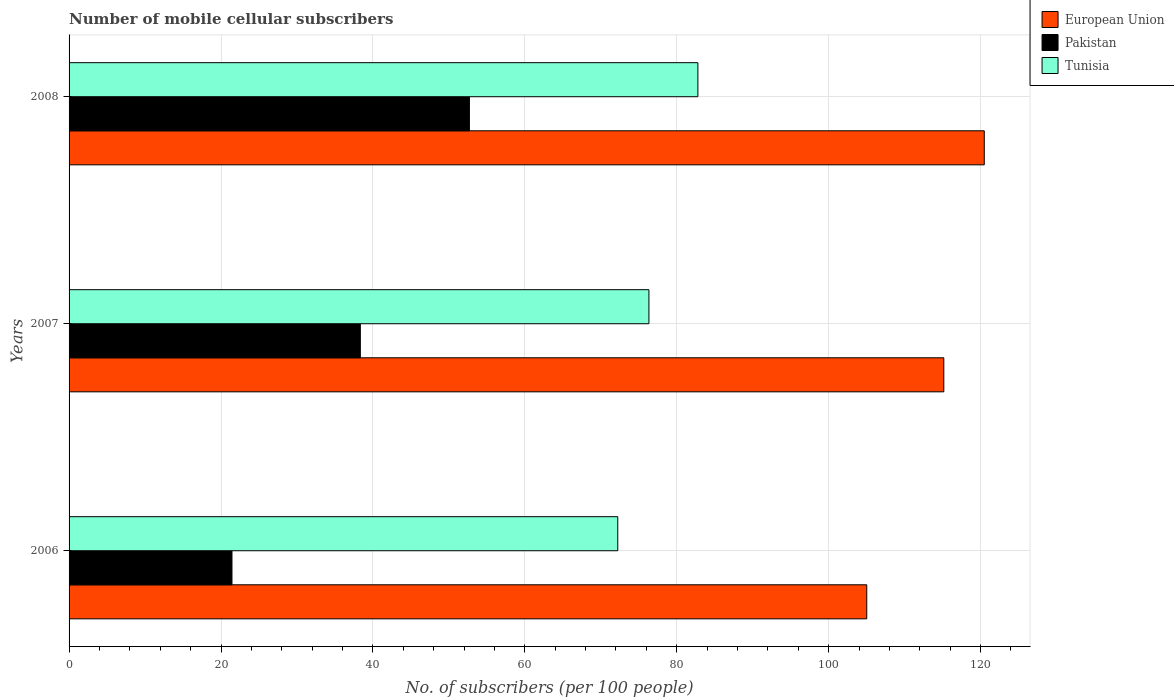How many different coloured bars are there?
Ensure brevity in your answer.  3. Are the number of bars per tick equal to the number of legend labels?
Offer a terse response. Yes. Are the number of bars on each tick of the Y-axis equal?
Your answer should be compact. Yes. How many bars are there on the 3rd tick from the top?
Provide a short and direct response. 3. How many bars are there on the 3rd tick from the bottom?
Your answer should be compact. 3. What is the label of the 3rd group of bars from the top?
Keep it short and to the point. 2006. In how many cases, is the number of bars for a given year not equal to the number of legend labels?
Keep it short and to the point. 0. What is the number of mobile cellular subscribers in European Union in 2007?
Your response must be concise. 115.16. Across all years, what is the maximum number of mobile cellular subscribers in European Union?
Make the answer very short. 120.48. Across all years, what is the minimum number of mobile cellular subscribers in Pakistan?
Your answer should be compact. 21.45. What is the total number of mobile cellular subscribers in European Union in the graph?
Make the answer very short. 340.65. What is the difference between the number of mobile cellular subscribers in European Union in 2007 and that in 2008?
Offer a terse response. -5.33. What is the difference between the number of mobile cellular subscribers in Pakistan in 2008 and the number of mobile cellular subscribers in European Union in 2007?
Your answer should be compact. -62.45. What is the average number of mobile cellular subscribers in Pakistan per year?
Give a very brief answer. 37.5. In the year 2006, what is the difference between the number of mobile cellular subscribers in European Union and number of mobile cellular subscribers in Pakistan?
Ensure brevity in your answer.  83.57. In how many years, is the number of mobile cellular subscribers in Pakistan greater than 32 ?
Your response must be concise. 2. What is the ratio of the number of mobile cellular subscribers in European Union in 2007 to that in 2008?
Your answer should be compact. 0.96. Is the difference between the number of mobile cellular subscribers in European Union in 2006 and 2008 greater than the difference between the number of mobile cellular subscribers in Pakistan in 2006 and 2008?
Make the answer very short. Yes. What is the difference between the highest and the second highest number of mobile cellular subscribers in European Union?
Make the answer very short. 5.33. What is the difference between the highest and the lowest number of mobile cellular subscribers in Tunisia?
Your answer should be very brief. 10.55. In how many years, is the number of mobile cellular subscribers in Tunisia greater than the average number of mobile cellular subscribers in Tunisia taken over all years?
Provide a succinct answer. 1. Is the sum of the number of mobile cellular subscribers in Tunisia in 2006 and 2007 greater than the maximum number of mobile cellular subscribers in Pakistan across all years?
Your answer should be very brief. Yes. Is it the case that in every year, the sum of the number of mobile cellular subscribers in European Union and number of mobile cellular subscribers in Tunisia is greater than the number of mobile cellular subscribers in Pakistan?
Keep it short and to the point. Yes. How many years are there in the graph?
Ensure brevity in your answer.  3. Are the values on the major ticks of X-axis written in scientific E-notation?
Your answer should be very brief. No. Does the graph contain any zero values?
Your answer should be very brief. No. Where does the legend appear in the graph?
Offer a very short reply. Top right. How are the legend labels stacked?
Offer a terse response. Vertical. What is the title of the graph?
Your answer should be very brief. Number of mobile cellular subscribers. Does "Sri Lanka" appear as one of the legend labels in the graph?
Ensure brevity in your answer.  No. What is the label or title of the X-axis?
Give a very brief answer. No. of subscribers (per 100 people). What is the label or title of the Y-axis?
Give a very brief answer. Years. What is the No. of subscribers (per 100 people) in European Union in 2006?
Keep it short and to the point. 105.01. What is the No. of subscribers (per 100 people) in Pakistan in 2006?
Make the answer very short. 21.45. What is the No. of subscribers (per 100 people) in Tunisia in 2006?
Your answer should be very brief. 72.23. What is the No. of subscribers (per 100 people) of European Union in 2007?
Offer a terse response. 115.16. What is the No. of subscribers (per 100 people) of Pakistan in 2007?
Ensure brevity in your answer.  38.34. What is the No. of subscribers (per 100 people) in Tunisia in 2007?
Give a very brief answer. 76.34. What is the No. of subscribers (per 100 people) of European Union in 2008?
Make the answer very short. 120.48. What is the No. of subscribers (per 100 people) of Pakistan in 2008?
Keep it short and to the point. 52.7. What is the No. of subscribers (per 100 people) in Tunisia in 2008?
Offer a very short reply. 82.78. Across all years, what is the maximum No. of subscribers (per 100 people) in European Union?
Your answer should be compact. 120.48. Across all years, what is the maximum No. of subscribers (per 100 people) in Pakistan?
Your answer should be compact. 52.7. Across all years, what is the maximum No. of subscribers (per 100 people) of Tunisia?
Your response must be concise. 82.78. Across all years, what is the minimum No. of subscribers (per 100 people) in European Union?
Ensure brevity in your answer.  105.01. Across all years, what is the minimum No. of subscribers (per 100 people) of Pakistan?
Make the answer very short. 21.45. Across all years, what is the minimum No. of subscribers (per 100 people) in Tunisia?
Keep it short and to the point. 72.23. What is the total No. of subscribers (per 100 people) of European Union in the graph?
Your answer should be compact. 340.65. What is the total No. of subscribers (per 100 people) in Pakistan in the graph?
Your answer should be very brief. 112.49. What is the total No. of subscribers (per 100 people) in Tunisia in the graph?
Provide a short and direct response. 231.35. What is the difference between the No. of subscribers (per 100 people) of European Union in 2006 and that in 2007?
Make the answer very short. -10.14. What is the difference between the No. of subscribers (per 100 people) of Pakistan in 2006 and that in 2007?
Keep it short and to the point. -16.9. What is the difference between the No. of subscribers (per 100 people) in Tunisia in 2006 and that in 2007?
Ensure brevity in your answer.  -4.1. What is the difference between the No. of subscribers (per 100 people) of European Union in 2006 and that in 2008?
Provide a succinct answer. -15.47. What is the difference between the No. of subscribers (per 100 people) in Pakistan in 2006 and that in 2008?
Provide a short and direct response. -31.26. What is the difference between the No. of subscribers (per 100 people) in Tunisia in 2006 and that in 2008?
Offer a very short reply. -10.55. What is the difference between the No. of subscribers (per 100 people) in European Union in 2007 and that in 2008?
Your response must be concise. -5.33. What is the difference between the No. of subscribers (per 100 people) in Pakistan in 2007 and that in 2008?
Your answer should be compact. -14.36. What is the difference between the No. of subscribers (per 100 people) in Tunisia in 2007 and that in 2008?
Offer a terse response. -6.45. What is the difference between the No. of subscribers (per 100 people) in European Union in 2006 and the No. of subscribers (per 100 people) in Pakistan in 2007?
Your response must be concise. 66.67. What is the difference between the No. of subscribers (per 100 people) in European Union in 2006 and the No. of subscribers (per 100 people) in Tunisia in 2007?
Give a very brief answer. 28.68. What is the difference between the No. of subscribers (per 100 people) of Pakistan in 2006 and the No. of subscribers (per 100 people) of Tunisia in 2007?
Your response must be concise. -54.89. What is the difference between the No. of subscribers (per 100 people) of European Union in 2006 and the No. of subscribers (per 100 people) of Pakistan in 2008?
Offer a very short reply. 52.31. What is the difference between the No. of subscribers (per 100 people) in European Union in 2006 and the No. of subscribers (per 100 people) in Tunisia in 2008?
Provide a short and direct response. 22.23. What is the difference between the No. of subscribers (per 100 people) in Pakistan in 2006 and the No. of subscribers (per 100 people) in Tunisia in 2008?
Provide a succinct answer. -61.34. What is the difference between the No. of subscribers (per 100 people) in European Union in 2007 and the No. of subscribers (per 100 people) in Pakistan in 2008?
Your answer should be very brief. 62.45. What is the difference between the No. of subscribers (per 100 people) in European Union in 2007 and the No. of subscribers (per 100 people) in Tunisia in 2008?
Offer a terse response. 32.38. What is the difference between the No. of subscribers (per 100 people) of Pakistan in 2007 and the No. of subscribers (per 100 people) of Tunisia in 2008?
Provide a short and direct response. -44.44. What is the average No. of subscribers (per 100 people) in European Union per year?
Ensure brevity in your answer.  113.55. What is the average No. of subscribers (per 100 people) of Pakistan per year?
Your answer should be compact. 37.5. What is the average No. of subscribers (per 100 people) of Tunisia per year?
Offer a terse response. 77.12. In the year 2006, what is the difference between the No. of subscribers (per 100 people) of European Union and No. of subscribers (per 100 people) of Pakistan?
Your response must be concise. 83.57. In the year 2006, what is the difference between the No. of subscribers (per 100 people) in European Union and No. of subscribers (per 100 people) in Tunisia?
Keep it short and to the point. 32.78. In the year 2006, what is the difference between the No. of subscribers (per 100 people) of Pakistan and No. of subscribers (per 100 people) of Tunisia?
Make the answer very short. -50.79. In the year 2007, what is the difference between the No. of subscribers (per 100 people) in European Union and No. of subscribers (per 100 people) in Pakistan?
Your answer should be very brief. 76.81. In the year 2007, what is the difference between the No. of subscribers (per 100 people) in European Union and No. of subscribers (per 100 people) in Tunisia?
Your answer should be very brief. 38.82. In the year 2007, what is the difference between the No. of subscribers (per 100 people) in Pakistan and No. of subscribers (per 100 people) in Tunisia?
Your answer should be compact. -37.99. In the year 2008, what is the difference between the No. of subscribers (per 100 people) of European Union and No. of subscribers (per 100 people) of Pakistan?
Offer a terse response. 67.78. In the year 2008, what is the difference between the No. of subscribers (per 100 people) in European Union and No. of subscribers (per 100 people) in Tunisia?
Ensure brevity in your answer.  37.7. In the year 2008, what is the difference between the No. of subscribers (per 100 people) of Pakistan and No. of subscribers (per 100 people) of Tunisia?
Your answer should be compact. -30.08. What is the ratio of the No. of subscribers (per 100 people) of European Union in 2006 to that in 2007?
Offer a terse response. 0.91. What is the ratio of the No. of subscribers (per 100 people) in Pakistan in 2006 to that in 2007?
Offer a terse response. 0.56. What is the ratio of the No. of subscribers (per 100 people) of Tunisia in 2006 to that in 2007?
Offer a terse response. 0.95. What is the ratio of the No. of subscribers (per 100 people) of European Union in 2006 to that in 2008?
Keep it short and to the point. 0.87. What is the ratio of the No. of subscribers (per 100 people) in Pakistan in 2006 to that in 2008?
Make the answer very short. 0.41. What is the ratio of the No. of subscribers (per 100 people) in Tunisia in 2006 to that in 2008?
Offer a terse response. 0.87. What is the ratio of the No. of subscribers (per 100 people) in European Union in 2007 to that in 2008?
Offer a terse response. 0.96. What is the ratio of the No. of subscribers (per 100 people) of Pakistan in 2007 to that in 2008?
Provide a succinct answer. 0.73. What is the ratio of the No. of subscribers (per 100 people) in Tunisia in 2007 to that in 2008?
Your answer should be compact. 0.92. What is the difference between the highest and the second highest No. of subscribers (per 100 people) of European Union?
Your answer should be very brief. 5.33. What is the difference between the highest and the second highest No. of subscribers (per 100 people) in Pakistan?
Provide a succinct answer. 14.36. What is the difference between the highest and the second highest No. of subscribers (per 100 people) in Tunisia?
Offer a very short reply. 6.45. What is the difference between the highest and the lowest No. of subscribers (per 100 people) of European Union?
Ensure brevity in your answer.  15.47. What is the difference between the highest and the lowest No. of subscribers (per 100 people) in Pakistan?
Offer a terse response. 31.26. What is the difference between the highest and the lowest No. of subscribers (per 100 people) of Tunisia?
Your answer should be very brief. 10.55. 